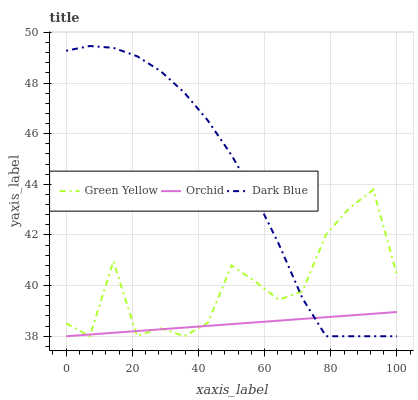Does Orchid have the minimum area under the curve?
Answer yes or no. Yes. Does Dark Blue have the maximum area under the curve?
Answer yes or no. Yes. Does Green Yellow have the minimum area under the curve?
Answer yes or no. No. Does Green Yellow have the maximum area under the curve?
Answer yes or no. No. Is Orchid the smoothest?
Answer yes or no. Yes. Is Green Yellow the roughest?
Answer yes or no. Yes. Is Green Yellow the smoothest?
Answer yes or no. No. Is Orchid the roughest?
Answer yes or no. No. Does Dark Blue have the highest value?
Answer yes or no. Yes. Does Green Yellow have the highest value?
Answer yes or no. No. Does Dark Blue intersect Green Yellow?
Answer yes or no. Yes. Is Dark Blue less than Green Yellow?
Answer yes or no. No. Is Dark Blue greater than Green Yellow?
Answer yes or no. No. 